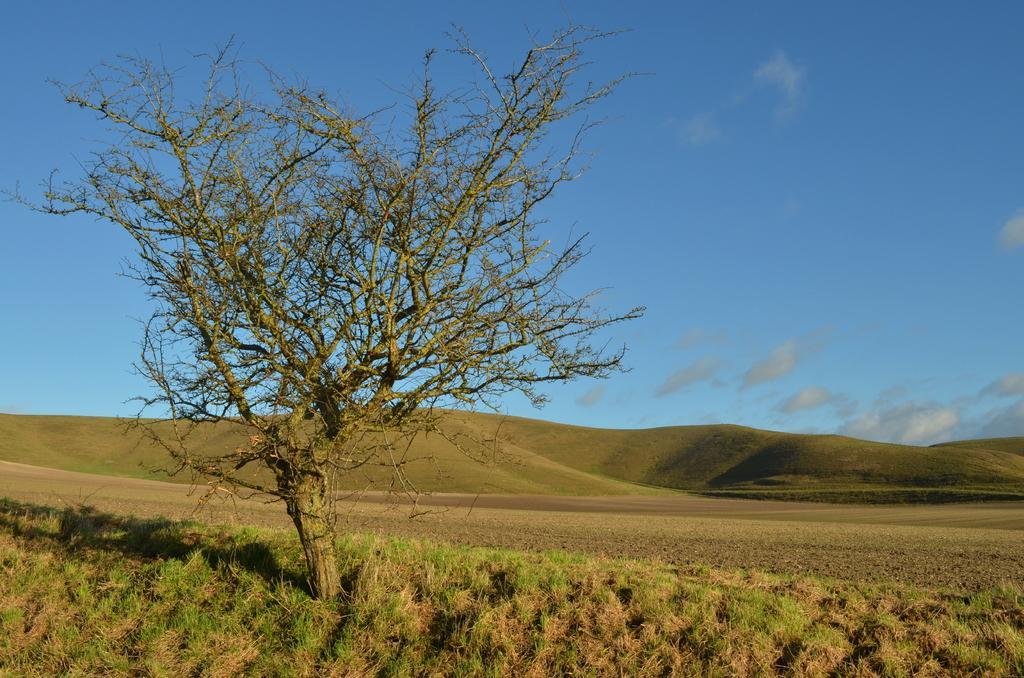Could you give a brief overview of what you see in this image? At the bottom of the image I can see the grass. On the left side of the image I can see one tree. There is a sky on the top of this image. 